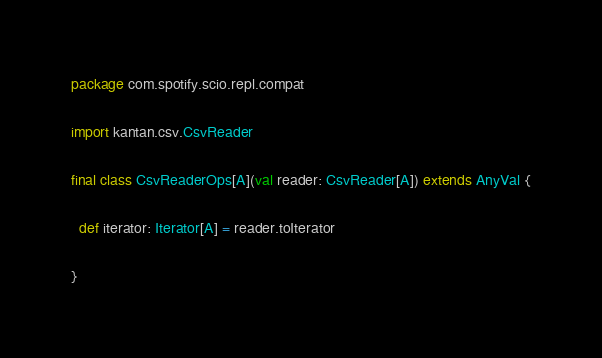Convert code to text. <code><loc_0><loc_0><loc_500><loc_500><_Scala_>package com.spotify.scio.repl.compat

import kantan.csv.CsvReader

final class CsvReaderOps[A](val reader: CsvReader[A]) extends AnyVal {

  def iterator: Iterator[A] = reader.toIterator

}
</code> 